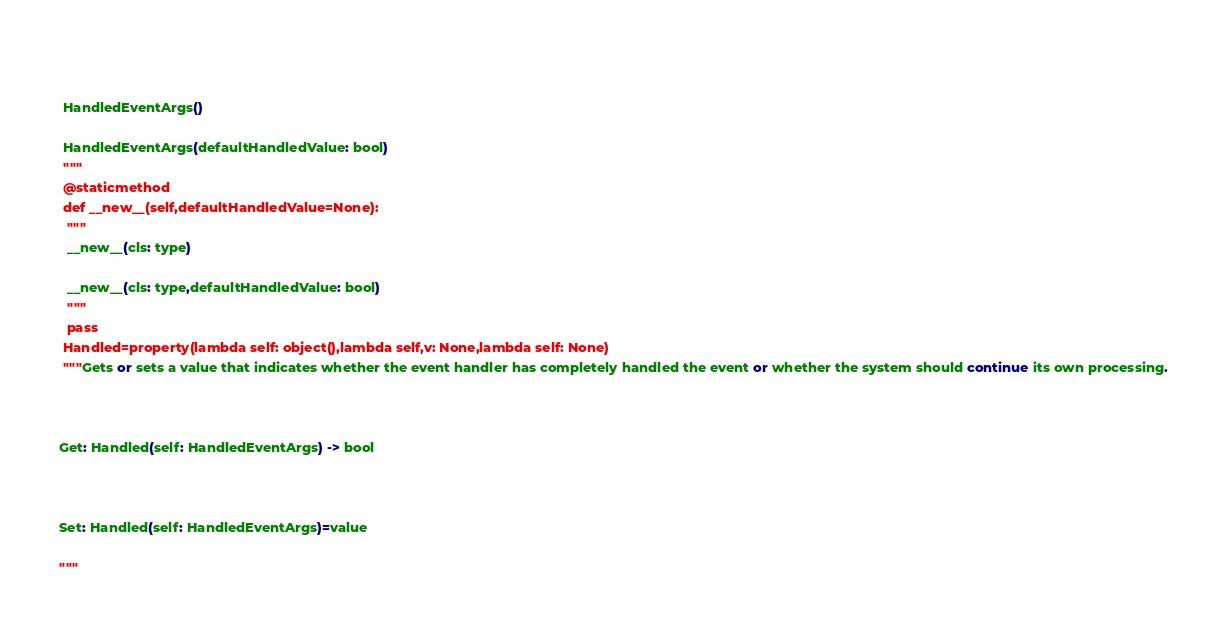Convert code to text. <code><loc_0><loc_0><loc_500><loc_500><_Python_> 
 HandledEventArgs()
 HandledEventArgs(defaultHandledValue: bool)
 """
 @staticmethod
 def __new__(self,defaultHandledValue=None):
  """
  __new__(cls: type)
  __new__(cls: type,defaultHandledValue: bool)
  """
  pass
 Handled=property(lambda self: object(),lambda self,v: None,lambda self: None)
 """Gets or sets a value that indicates whether the event handler has completely handled the event or whether the system should continue its own processing.

Get: Handled(self: HandledEventArgs) -> bool

Set: Handled(self: HandledEventArgs)=value
"""


</code> 